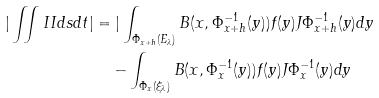Convert formula to latex. <formula><loc_0><loc_0><loc_500><loc_500>| \iint I I d s d t | & = | \int _ { \Phi _ { x + h } ( E _ { \lambda } ) } B ( x , \Phi ^ { - 1 } _ { x + h } ( y ) ) f ( y ) J \Phi ^ { - 1 } _ { x + h } ( y ) d y \\ & \quad - \int _ { \Phi _ { x } ( \xi _ { \lambda } ) } B ( x , \Phi _ { x } ^ { - 1 } ( y ) ) f ( y ) J \Phi ^ { - 1 } _ { x } ( y ) d y</formula> 